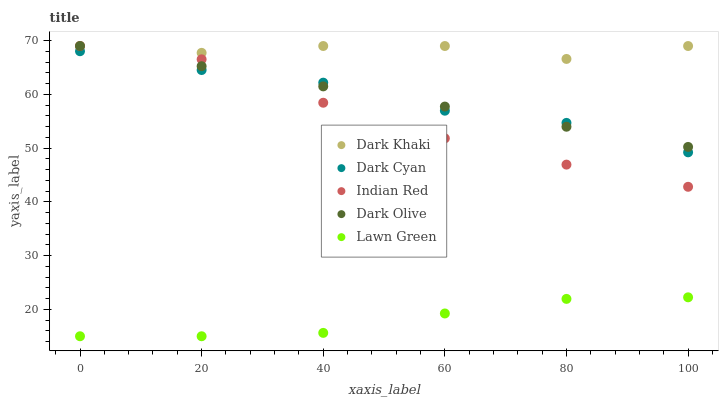Does Lawn Green have the minimum area under the curve?
Answer yes or no. Yes. Does Dark Khaki have the maximum area under the curve?
Answer yes or no. Yes. Does Dark Cyan have the minimum area under the curve?
Answer yes or no. No. Does Dark Cyan have the maximum area under the curve?
Answer yes or no. No. Is Dark Olive the smoothest?
Answer yes or no. Yes. Is Dark Khaki the roughest?
Answer yes or no. Yes. Is Dark Cyan the smoothest?
Answer yes or no. No. Is Dark Cyan the roughest?
Answer yes or no. No. Does Lawn Green have the lowest value?
Answer yes or no. Yes. Does Dark Cyan have the lowest value?
Answer yes or no. No. Does Indian Red have the highest value?
Answer yes or no. Yes. Does Dark Cyan have the highest value?
Answer yes or no. No. Is Lawn Green less than Indian Red?
Answer yes or no. Yes. Is Dark Khaki greater than Lawn Green?
Answer yes or no. Yes. Does Dark Khaki intersect Dark Olive?
Answer yes or no. Yes. Is Dark Khaki less than Dark Olive?
Answer yes or no. No. Is Dark Khaki greater than Dark Olive?
Answer yes or no. No. Does Lawn Green intersect Indian Red?
Answer yes or no. No. 